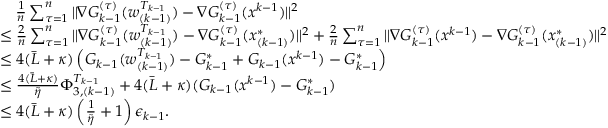<formula> <loc_0><loc_0><loc_500><loc_500>\begin{array} { r l } & { \quad \frac { 1 } { n } \sum _ { \tau = 1 } ^ { n } \| \nabla G _ { k - 1 } ^ { ( \tau ) } ( w _ { ( k - 1 ) } ^ { T _ { k - 1 } } ) - \nabla G _ { k - 1 } ^ { ( \tau ) } ( x ^ { k - 1 } ) \| ^ { 2 } } \\ & { \leq \frac { 2 } { n } \sum _ { \tau = 1 } ^ { n } \| \nabla G _ { k - 1 } ^ { ( \tau ) } ( w _ { ( k - 1 ) } ^ { T _ { k - 1 } } ) - \nabla G _ { k - 1 } ^ { ( \tau ) } ( x _ { ( k - 1 ) } ^ { * } ) \| ^ { 2 } + \frac { 2 } { n } \sum _ { \tau = 1 } ^ { n } \| \nabla G _ { k - 1 } ^ { ( \tau ) } ( x ^ { k - 1 } ) - \nabla G _ { k - 1 } ^ { ( \tau ) } ( x _ { ( k - 1 ) } ^ { * } ) \| ^ { 2 } } \\ & { \leq 4 ( { \bar { L } } + \kappa ) \left ( G _ { k - 1 } ( w _ { ( k - 1 ) } ^ { T _ { k - 1 } } ) - G _ { k - 1 } ^ { * } + G _ { k - 1 } ( x ^ { k - 1 } ) - G _ { k - 1 } ^ { * } \right ) } \\ & { \leq \frac { 4 ( { \bar { L } } + \kappa ) } { { \tilde { \eta } } } \Phi _ { 3 , ( k - 1 ) } ^ { T _ { k - 1 } } + 4 ( { \bar { L } } + \kappa ) ( G _ { k - 1 } ( x ^ { k - 1 } ) - G _ { k - 1 } ^ { * } ) } \\ & { \leq 4 ( { \bar { L } } + \kappa ) \left ( \frac { 1 } { \tilde { \eta } } + 1 \right ) \epsilon _ { k - 1 } . } \end{array}</formula> 